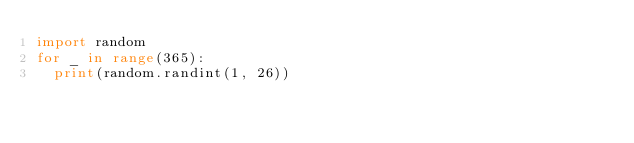<code> <loc_0><loc_0><loc_500><loc_500><_Python_>import random
for _ in range(365):
  print(random.randint(1, 26))</code> 